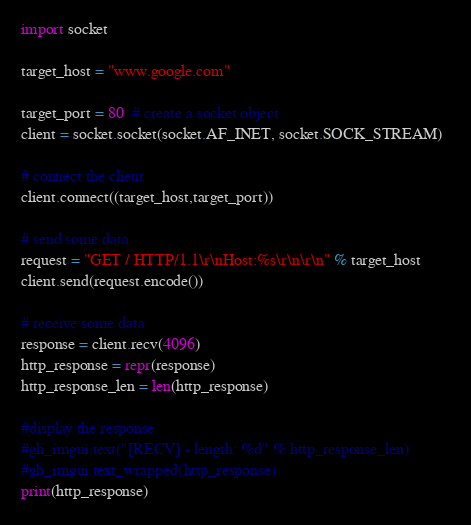Convert code to text. <code><loc_0><loc_0><loc_500><loc_500><_Python_>import socket

target_host = "www.google.com" 
 
target_port = 80  # create a socket object 
client = socket.socket(socket.AF_INET, socket.SOCK_STREAM)  
 
# connect the client 
client.connect((target_host,target_port))  
 
# send some data 
request = "GET / HTTP/1.1\r\nHost:%s\r\n\r\n" % target_host
client.send(request.encode())  
 
# receive some data 
response = client.recv(4096)  
http_response = repr(response)
http_response_len = len(http_response)
 
#display the response
#gh_imgui.text("[RECV] - length: %d" % http_response_len)
#gh_imgui.text_wrapped(http_response)
print(http_response)
</code> 